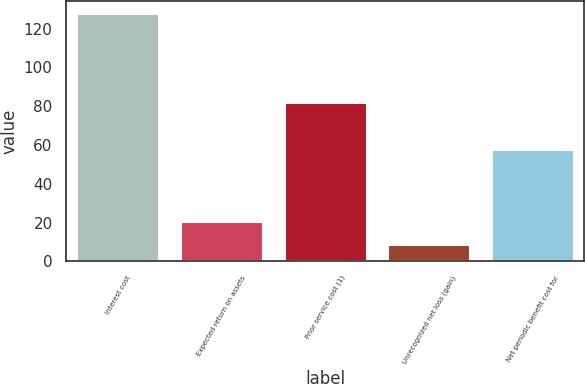<chart> <loc_0><loc_0><loc_500><loc_500><bar_chart><fcel>Interest cost<fcel>Expected return on assets<fcel>Prior service cost (1)<fcel>Unrecognized net loss (gain)<fcel>Net periodic benefit cost for<nl><fcel>128<fcel>20.9<fcel>82<fcel>9<fcel>58<nl></chart> 